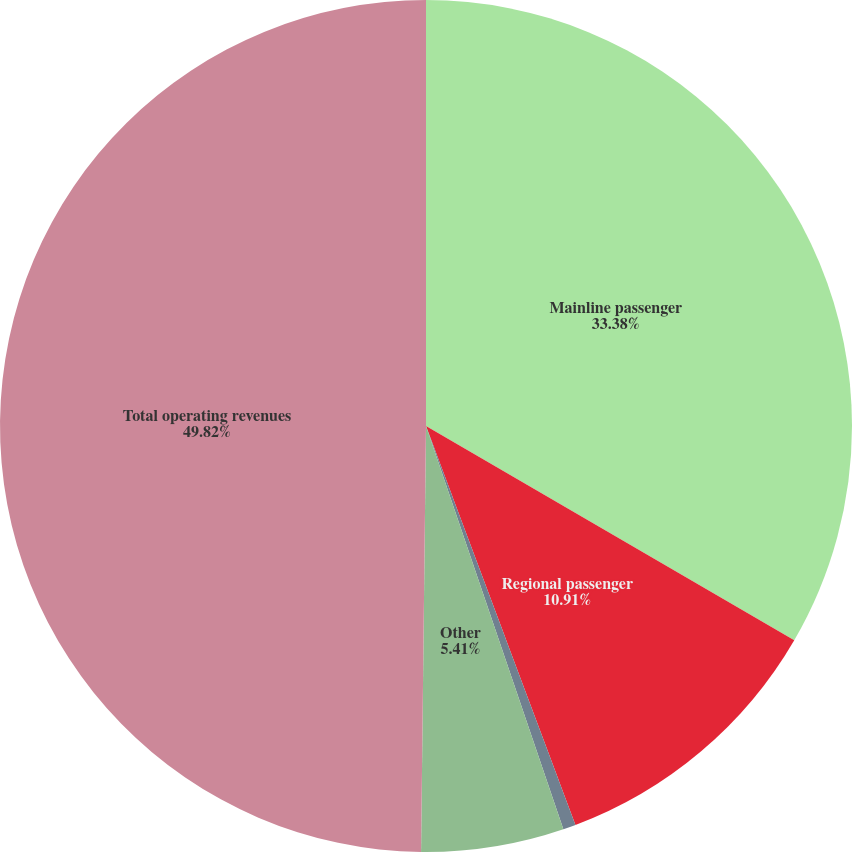Convert chart. <chart><loc_0><loc_0><loc_500><loc_500><pie_chart><fcel>Mainline passenger<fcel>Regional passenger<fcel>Cargo<fcel>Other<fcel>Total operating revenues<nl><fcel>33.38%<fcel>10.91%<fcel>0.48%<fcel>5.41%<fcel>49.81%<nl></chart> 